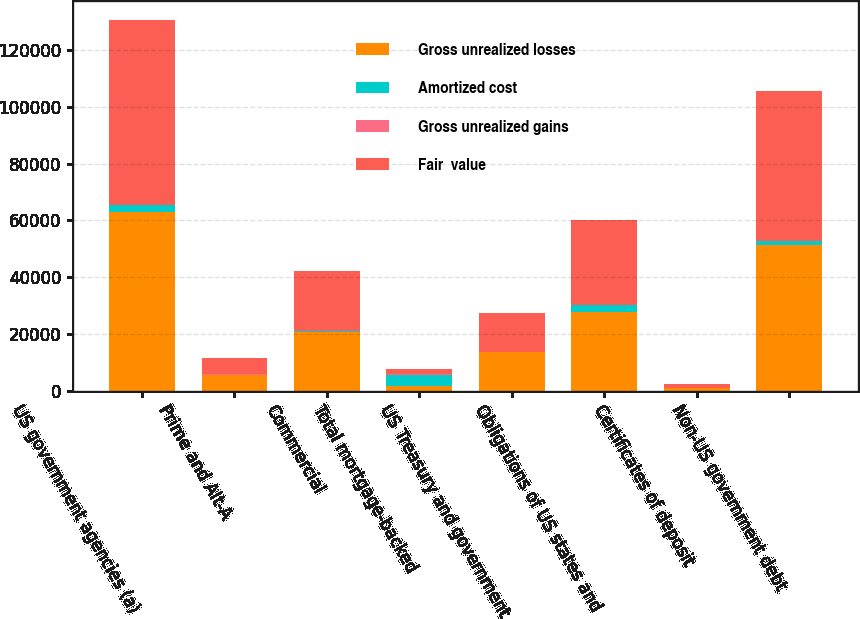Convert chart. <chart><loc_0><loc_0><loc_500><loc_500><stacked_bar_chart><ecel><fcel>US government agencies (a)<fcel>Prime and Alt-A<fcel>Commercial<fcel>Total mortgage-backed<fcel>US Treasury and government<fcel>Obligations of US states and<fcel>Certificates of deposit<fcel>Non-US government debt<nl><fcel>Gross unrealized losses<fcel>63089<fcel>5595<fcel>20687<fcel>1757.5<fcel>13603<fcel>27841<fcel>1103<fcel>51492<nl><fcel>Amortized cost<fcel>2302<fcel>78<fcel>438<fcel>3842<fcel>56<fcel>2243<fcel>1<fcel>1272<nl><fcel>Gross unrealized gains<fcel>72<fcel>29<fcel>17<fcel>118<fcel>14<fcel>16<fcel>1<fcel>21<nl><fcel>Fair  value<fcel>65319<fcel>5644<fcel>21108<fcel>1757.5<fcel>13645<fcel>30068<fcel>1103<fcel>52743<nl></chart> 